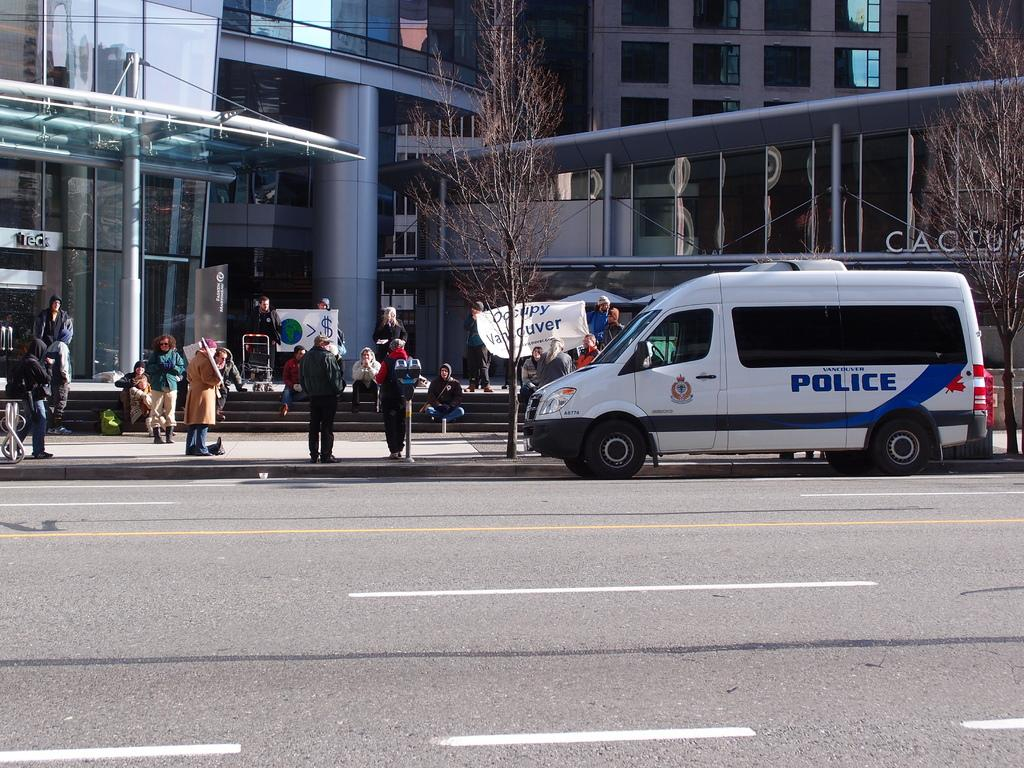<image>
Offer a succinct explanation of the picture presented. A police van is stopped near a crowd of people. 